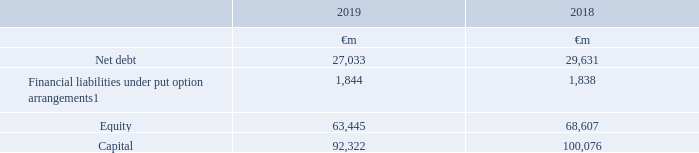Capital management
The following table summarises the capital of the Group at 31 March:
Note: 1 Financial liabilities under put option arrangements comprise liabilities for payments due to holders of the equity shares in Kabel Deutschland AG under the terms of a domination and profit and loss transfer agreement; the amounts at 31 March 2018 were previously presented within short-term borrowings
The Group’s policy is to borrow centrally using a mixture of long-term and short-term capital market issues and borrowing facilities to meet anticipated funding requirements. These borrowings, together with cash generated from operations, are loaned internally or contributed as equity to certain subsidiaries. The Board has approved three internal debt protection ratios being: net interest to operating cash flow (plus dividends from associates); retained cash flow (operating cash flow plus dividends from associates less interest, tax, dividends to non-controlling shareholders and equity dividends) to net debt; and operating cash flow (plus dividends from associates) to net debt. These internal ratios establish levels of debt that the Group should not exceed other than for relatively short periods of time and are shared with the Group’s debt rating agencies being Moody’s, Fitch Ratings and Standard & Poor’s.
What does the Group's capital comprise of? Net debt, financial liabilities under put option arrangements, equity. What does the table show? The capital of the group at 31 march. How much is the 2019 net debt?
Answer scale should be: million. 27,033. Between 2018 and 2019, which year had higher net debt? 29,631>27,033
Answer: 2018. Between 2018 and 2019, which year had a higher amount of equity?  68,607>63,445
Answer: 2018. Between 2018 and 2019, which year had a greater amount of capital? 100,076>92,322
Answer: 2018. 